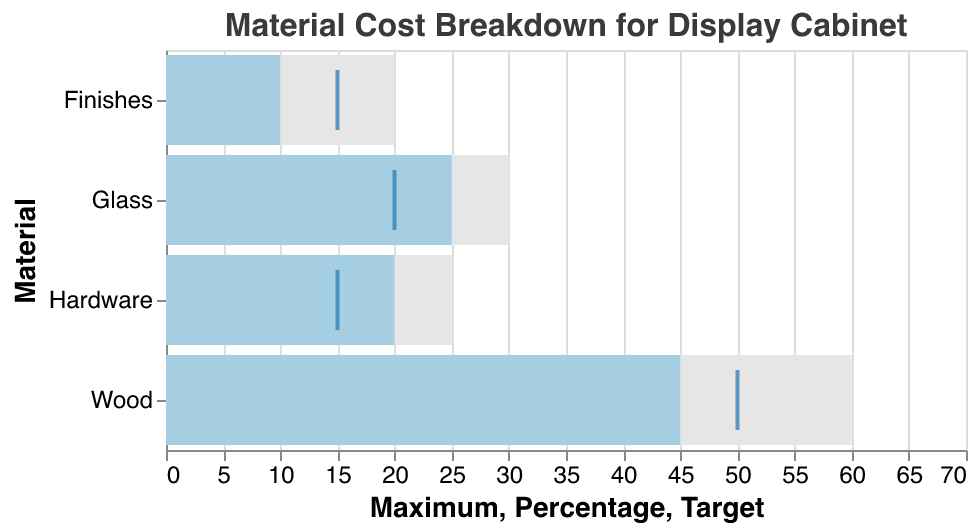What is the actual percentage of cost attributed to Wood? The percentage data shows that Wood accounts for 45% of the total cost.
Answer: 45% What material has the highest target percentage? By comparing the target percentages, we see that Wood has the highest target at 50%.
Answer: Wood How far is the actual cost percentage of Glass from its target? The target for Glass is 20%, and the actual percentage is 25%. The difference is 25% - 20% = 5%.
Answer: 5% Which material exceeds its target cost percentage the most? By comparing the actual vs. target percentages, Glass exceeds its target by 5%, while Wood is below its target by 5%, Hardware exceeds by 5%, and Finishes are below by 5%. Glass and Hardware exceed their targets by 5%.
Answer: Glass, Hardware Which material is the closest to its maximum allowable percentage? The maximum allowable percentage for Glass is 30%, and its actual percentage is 25%, which is 5% below the maximum. For Wood, Hardware, and Finishes, the differences are more significant.
Answer: Glass What is the title of the figure? The title "Material Cost Breakdown for Display Cabinet" is shown at the top of the figure.
Answer: Material Cost Breakdown for Display Cabinet How much does Finishes fall short of its target percentage? The target for Finishes is 15%, and the actual percentage is 10%. The shortfall is 15% - 10% = 5%.
Answer: 5% If the total cost is $200, how much is spent on Hardware? The actual cost percentage of Hardware is 20%. So, 20% of $200 = $200 * 0.20 = $40.
Answer: $40 Which material is significantly under its target percentage? Finishes have an actual percentage of 10% with a target of 15%, hence it falls short by 5%.
Answer: Finishes Are any materials over their maximum allowable percentage? Comparing the actual percentages with the maximum allowable percentages, none of the materials exceed their respective maximums.
Answer: No 